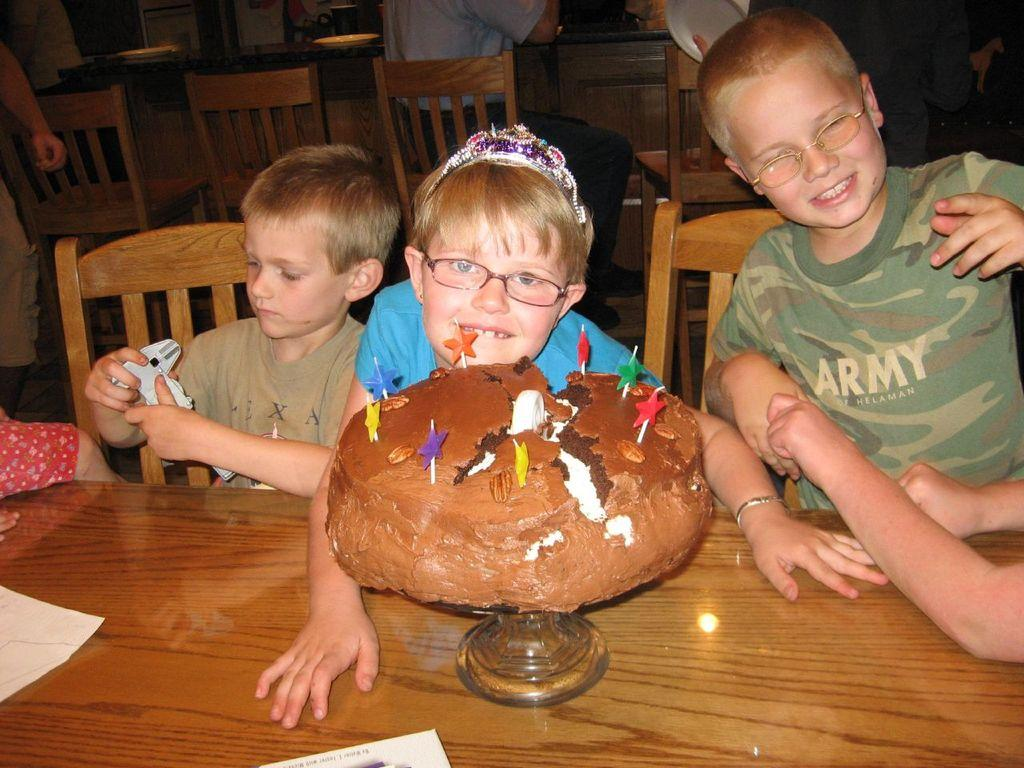How many children are present in the image? There are three children in the middle of the image. What is on the table in the image? There is a cake on a table in the image. What can be seen in the background of the image? There are chairs visible in the background of the image. What type of insurance policy is being discussed by the children in the image? There is no indication in the image that the children are discussing any insurance policies. 